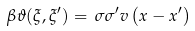Convert formula to latex. <formula><loc_0><loc_0><loc_500><loc_500>\beta \vartheta ( \xi , \xi ^ { \prime } ) = \, \sigma \sigma ^ { \prime } v \left ( x - x ^ { \prime } \right )</formula> 